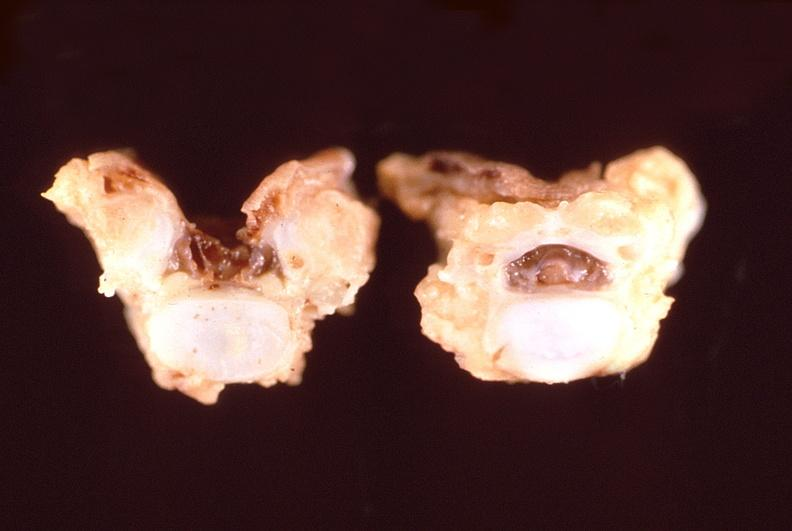s nervous present?
Answer the question using a single word or phrase. Yes 